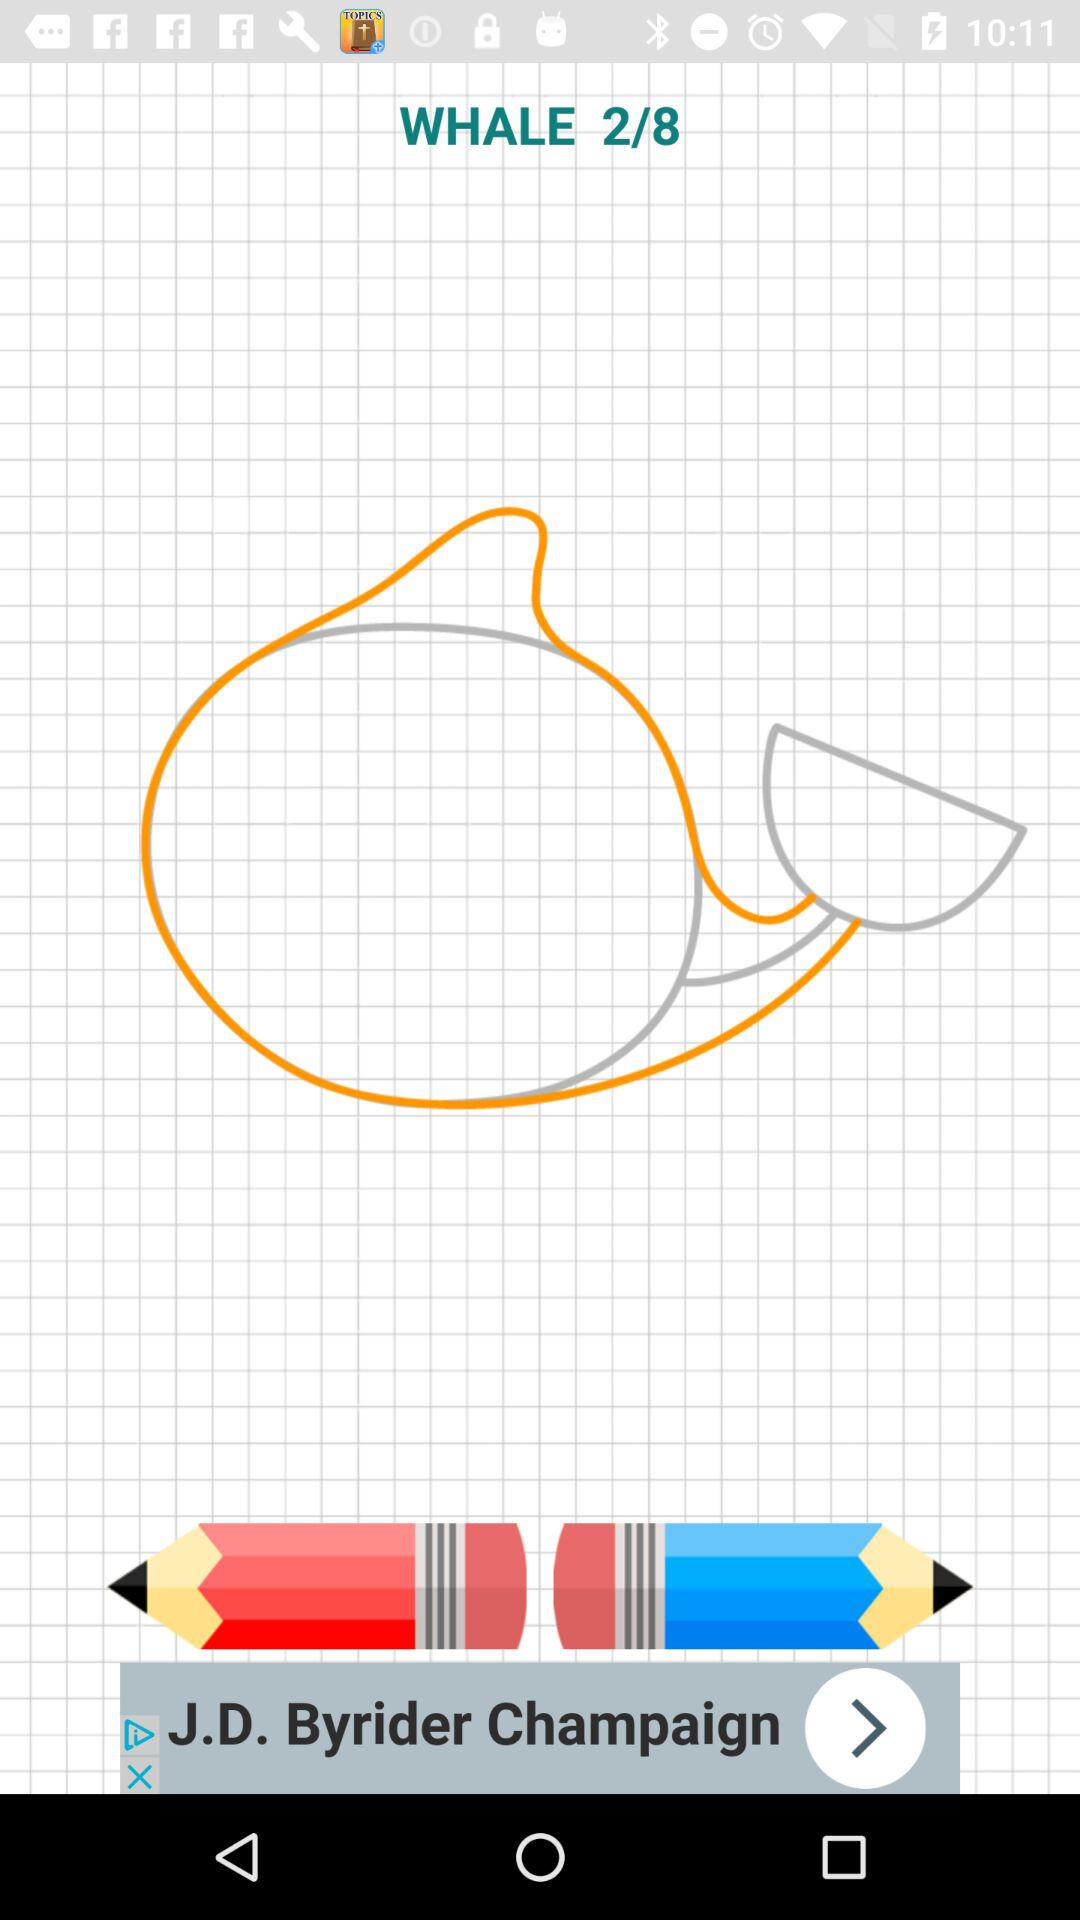How many pages in total are there? There are 8 pages in total. 